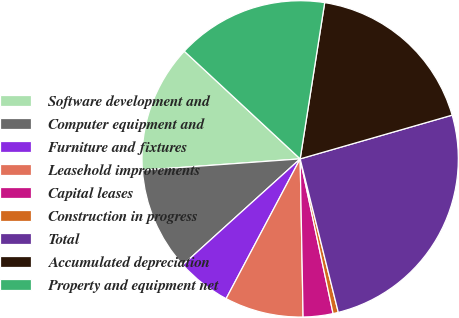<chart> <loc_0><loc_0><loc_500><loc_500><pie_chart><fcel>Software development and<fcel>Computer equipment and<fcel>Furniture and fixtures<fcel>Leasehold improvements<fcel>Capital leases<fcel>Construction in progress<fcel>Total<fcel>Accumulated depreciation<fcel>Property and equipment net<nl><fcel>13.06%<fcel>10.55%<fcel>5.55%<fcel>8.05%<fcel>3.04%<fcel>0.54%<fcel>25.58%<fcel>18.06%<fcel>15.56%<nl></chart> 